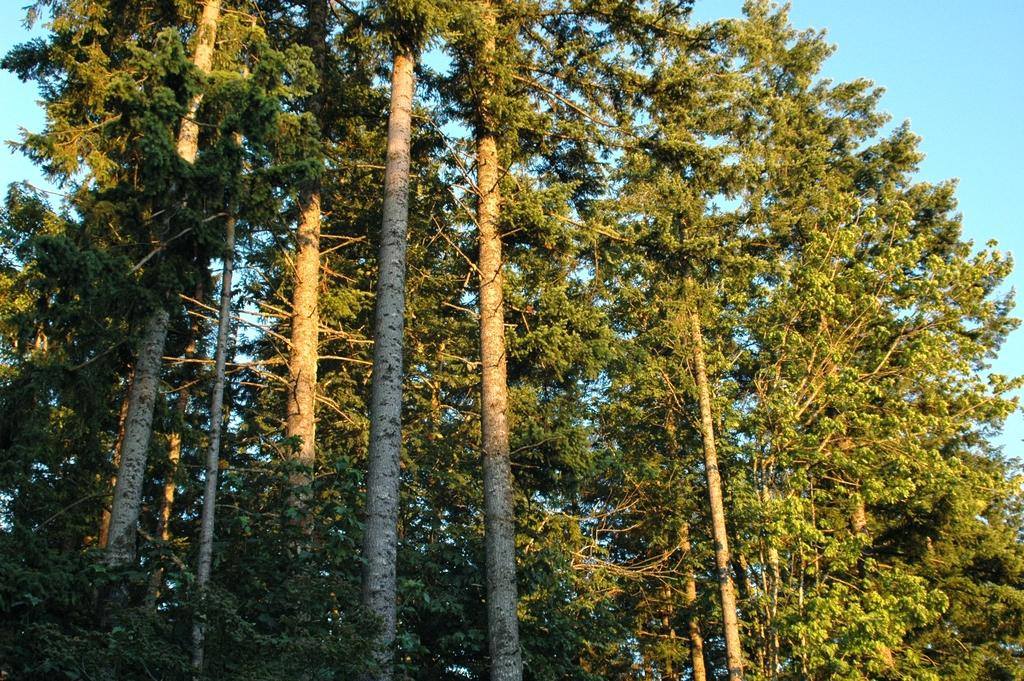Where was the image taken? The image was taken outdoors. What can be seen at the top of the image? The sky is visible at the top of the image. What type of vegetation is present in the image? There are many trees in the image. What is the color of the leaves on the trees? The trees have green leaves. What are the main components of the trees in the image? The trees have stems, branches, and green leaves. What company is responsible for the fact that the trees are running in the image? There are no trees running in the image, and no company is responsible for this non-existent action. 